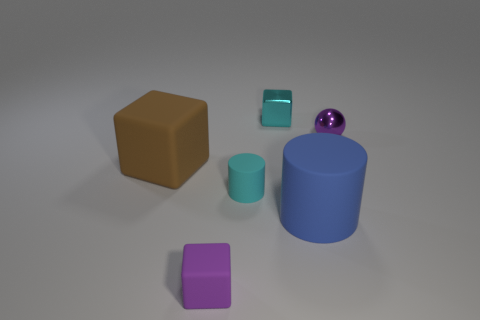What material is the small cyan thing that is left of the tiny block that is behind the small purple shiny object?
Offer a very short reply. Rubber. Is the size of the shiny ball the same as the cyan shiny thing?
Offer a terse response. Yes. How many small things are either brown rubber objects or metallic cubes?
Your response must be concise. 1. How many purple metal spheres are behind the metal sphere?
Provide a succinct answer. 0. Are there more big brown matte objects in front of the large brown cube than large rubber cubes?
Keep it short and to the point. No. The tiny purple thing that is the same material as the tiny cyan cylinder is what shape?
Your answer should be very brief. Cube. There is a tiny matte thing that is behind the purple thing on the left side of the big blue matte thing; what color is it?
Give a very brief answer. Cyan. Do the blue matte thing and the large brown matte thing have the same shape?
Ensure brevity in your answer.  No. What material is the large brown object that is the same shape as the tiny cyan shiny thing?
Offer a terse response. Rubber. Are there any small shiny balls left of the small cyan object that is on the right side of the tiny rubber thing that is behind the blue rubber thing?
Your answer should be compact. No. 